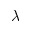Convert formula to latex. <formula><loc_0><loc_0><loc_500><loc_500>\lambda</formula> 